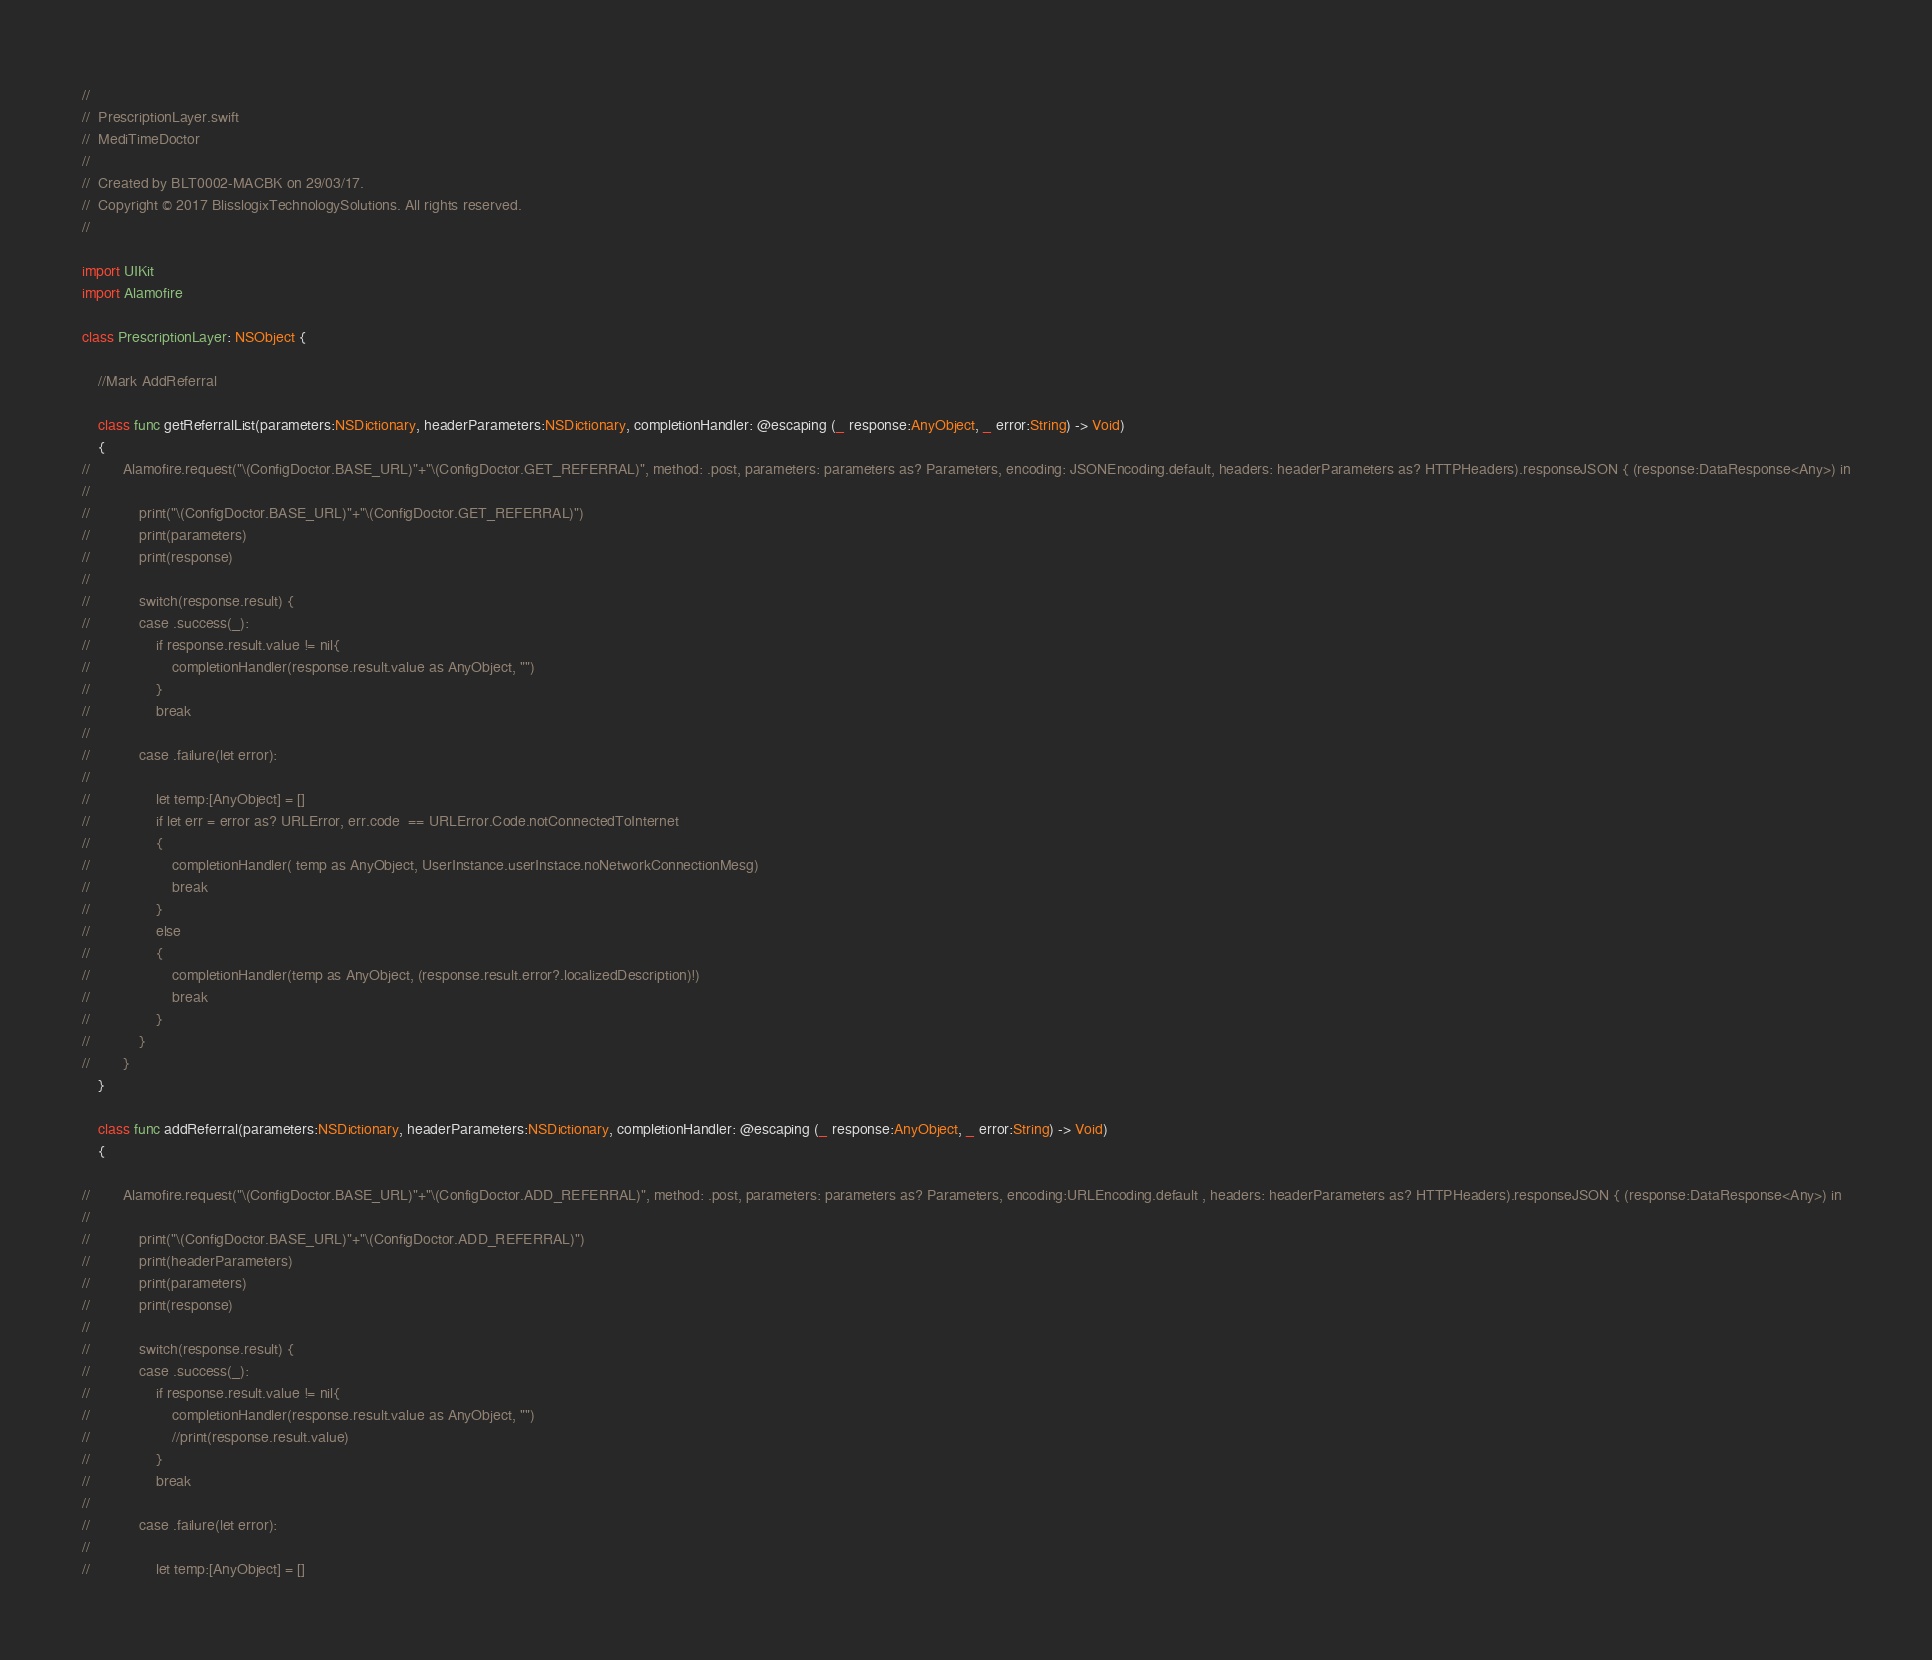Convert code to text. <code><loc_0><loc_0><loc_500><loc_500><_Swift_>//
//  PrescriptionLayer.swift
//  MediTimeDoctor
//
//  Created by BLT0002-MACBK on 29/03/17.
//  Copyright © 2017 BlisslogixTechnologySolutions. All rights reserved.
//

import UIKit
import Alamofire

class PrescriptionLayer: NSObject {
    
    //Mark AddReferral
    
    class func getReferralList(parameters:NSDictionary, headerParameters:NSDictionary, completionHandler: @escaping (_ response:AnyObject, _ error:String) -> Void)
    {
//        Alamofire.request("\(ConfigDoctor.BASE_URL)"+"\(ConfigDoctor.GET_REFERRAL)", method: .post, parameters: parameters as? Parameters, encoding: JSONEncoding.default, headers: headerParameters as? HTTPHeaders).responseJSON { (response:DataResponse<Any>) in
//
//            print("\(ConfigDoctor.BASE_URL)"+"\(ConfigDoctor.GET_REFERRAL)")
//            print(parameters)
//            print(response)
//
//            switch(response.result) {
//            case .success(_):
//                if response.result.value != nil{
//                    completionHandler(response.result.value as AnyObject, "")
//                }
//                break
//
//            case .failure(let error):
//
//                let temp:[AnyObject] = []
//                if let err = error as? URLError, err.code  == URLError.Code.notConnectedToInternet
//                {
//                    completionHandler( temp as AnyObject, UserInstance.userInstace.noNetworkConnectionMesg)
//                    break
//                }
//                else
//                {
//                    completionHandler(temp as AnyObject, (response.result.error?.localizedDescription)!)
//                    break
//                }
//            }
//        }
    }
    
    class func addReferral(parameters:NSDictionary, headerParameters:NSDictionary, completionHandler: @escaping (_ response:AnyObject, _ error:String) -> Void)
    {
        
//        Alamofire.request("\(ConfigDoctor.BASE_URL)"+"\(ConfigDoctor.ADD_REFERRAL)", method: .post, parameters: parameters as? Parameters, encoding:URLEncoding.default , headers: headerParameters as? HTTPHeaders).responseJSON { (response:DataResponse<Any>) in
//
//            print("\(ConfigDoctor.BASE_URL)"+"\(ConfigDoctor.ADD_REFERRAL)")
//            print(headerParameters)
//            print(parameters)
//            print(response)
//
//            switch(response.result) {
//            case .success(_):
//                if response.result.value != nil{
//                    completionHandler(response.result.value as AnyObject, "")
//                    //print(response.result.value)
//                }
//                break
//
//            case .failure(let error):
//
//                let temp:[AnyObject] = []</code> 